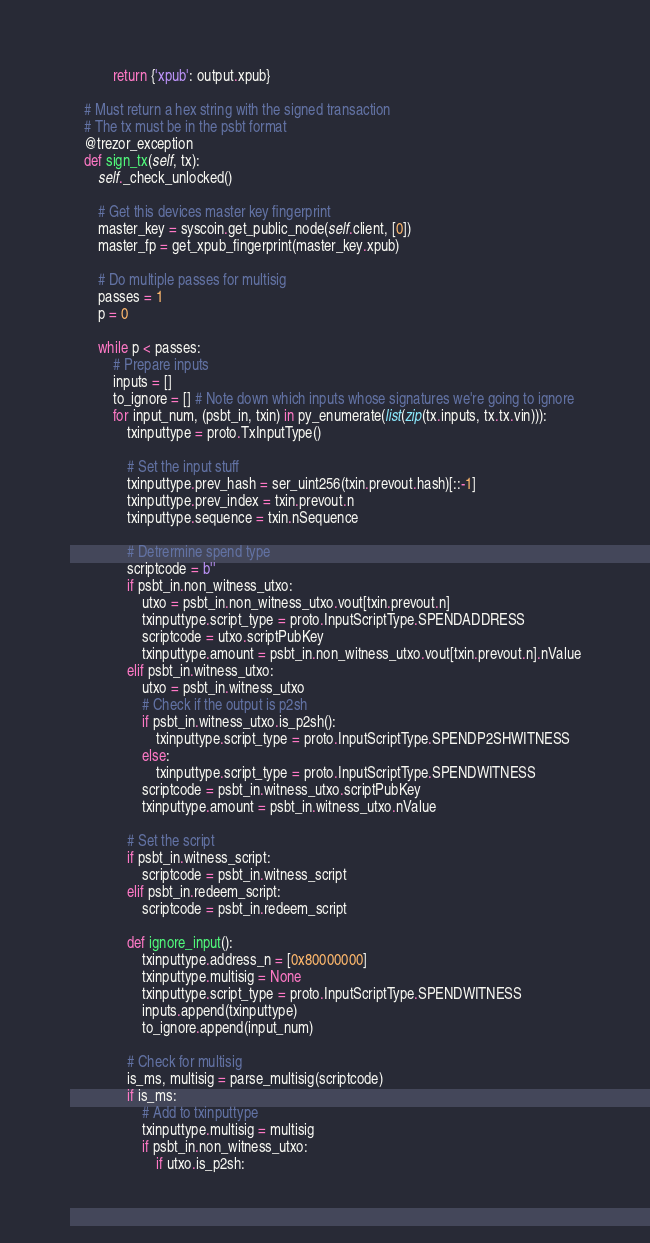Convert code to text. <code><loc_0><loc_0><loc_500><loc_500><_Python_>            return {'xpub': output.xpub}

    # Must return a hex string with the signed transaction
    # The tx must be in the psbt format
    @trezor_exception
    def sign_tx(self, tx):
        self._check_unlocked()

        # Get this devices master key fingerprint
        master_key = syscoin.get_public_node(self.client, [0])
        master_fp = get_xpub_fingerprint(master_key.xpub)

        # Do multiple passes for multisig
        passes = 1
        p = 0

        while p < passes:
            # Prepare inputs
            inputs = []
            to_ignore = [] # Note down which inputs whose signatures we're going to ignore
            for input_num, (psbt_in, txin) in py_enumerate(list(zip(tx.inputs, tx.tx.vin))):
                txinputtype = proto.TxInputType()

                # Set the input stuff
                txinputtype.prev_hash = ser_uint256(txin.prevout.hash)[::-1]
                txinputtype.prev_index = txin.prevout.n
                txinputtype.sequence = txin.nSequence

                # Detrermine spend type
                scriptcode = b''
                if psbt_in.non_witness_utxo:
                    utxo = psbt_in.non_witness_utxo.vout[txin.prevout.n]
                    txinputtype.script_type = proto.InputScriptType.SPENDADDRESS
                    scriptcode = utxo.scriptPubKey
                    txinputtype.amount = psbt_in.non_witness_utxo.vout[txin.prevout.n].nValue
                elif psbt_in.witness_utxo:
                    utxo = psbt_in.witness_utxo
                    # Check if the output is p2sh
                    if psbt_in.witness_utxo.is_p2sh():
                        txinputtype.script_type = proto.InputScriptType.SPENDP2SHWITNESS
                    else:
                        txinputtype.script_type = proto.InputScriptType.SPENDWITNESS
                    scriptcode = psbt_in.witness_utxo.scriptPubKey
                    txinputtype.amount = psbt_in.witness_utxo.nValue

                # Set the script
                if psbt_in.witness_script:
                    scriptcode = psbt_in.witness_script
                elif psbt_in.redeem_script:
                    scriptcode = psbt_in.redeem_script

                def ignore_input():
                    txinputtype.address_n = [0x80000000]
                    txinputtype.multisig = None
                    txinputtype.script_type = proto.InputScriptType.SPENDWITNESS
                    inputs.append(txinputtype)
                    to_ignore.append(input_num)

                # Check for multisig
                is_ms, multisig = parse_multisig(scriptcode)
                if is_ms:
                    # Add to txinputtype
                    txinputtype.multisig = multisig
                    if psbt_in.non_witness_utxo:
                        if utxo.is_p2sh:</code> 